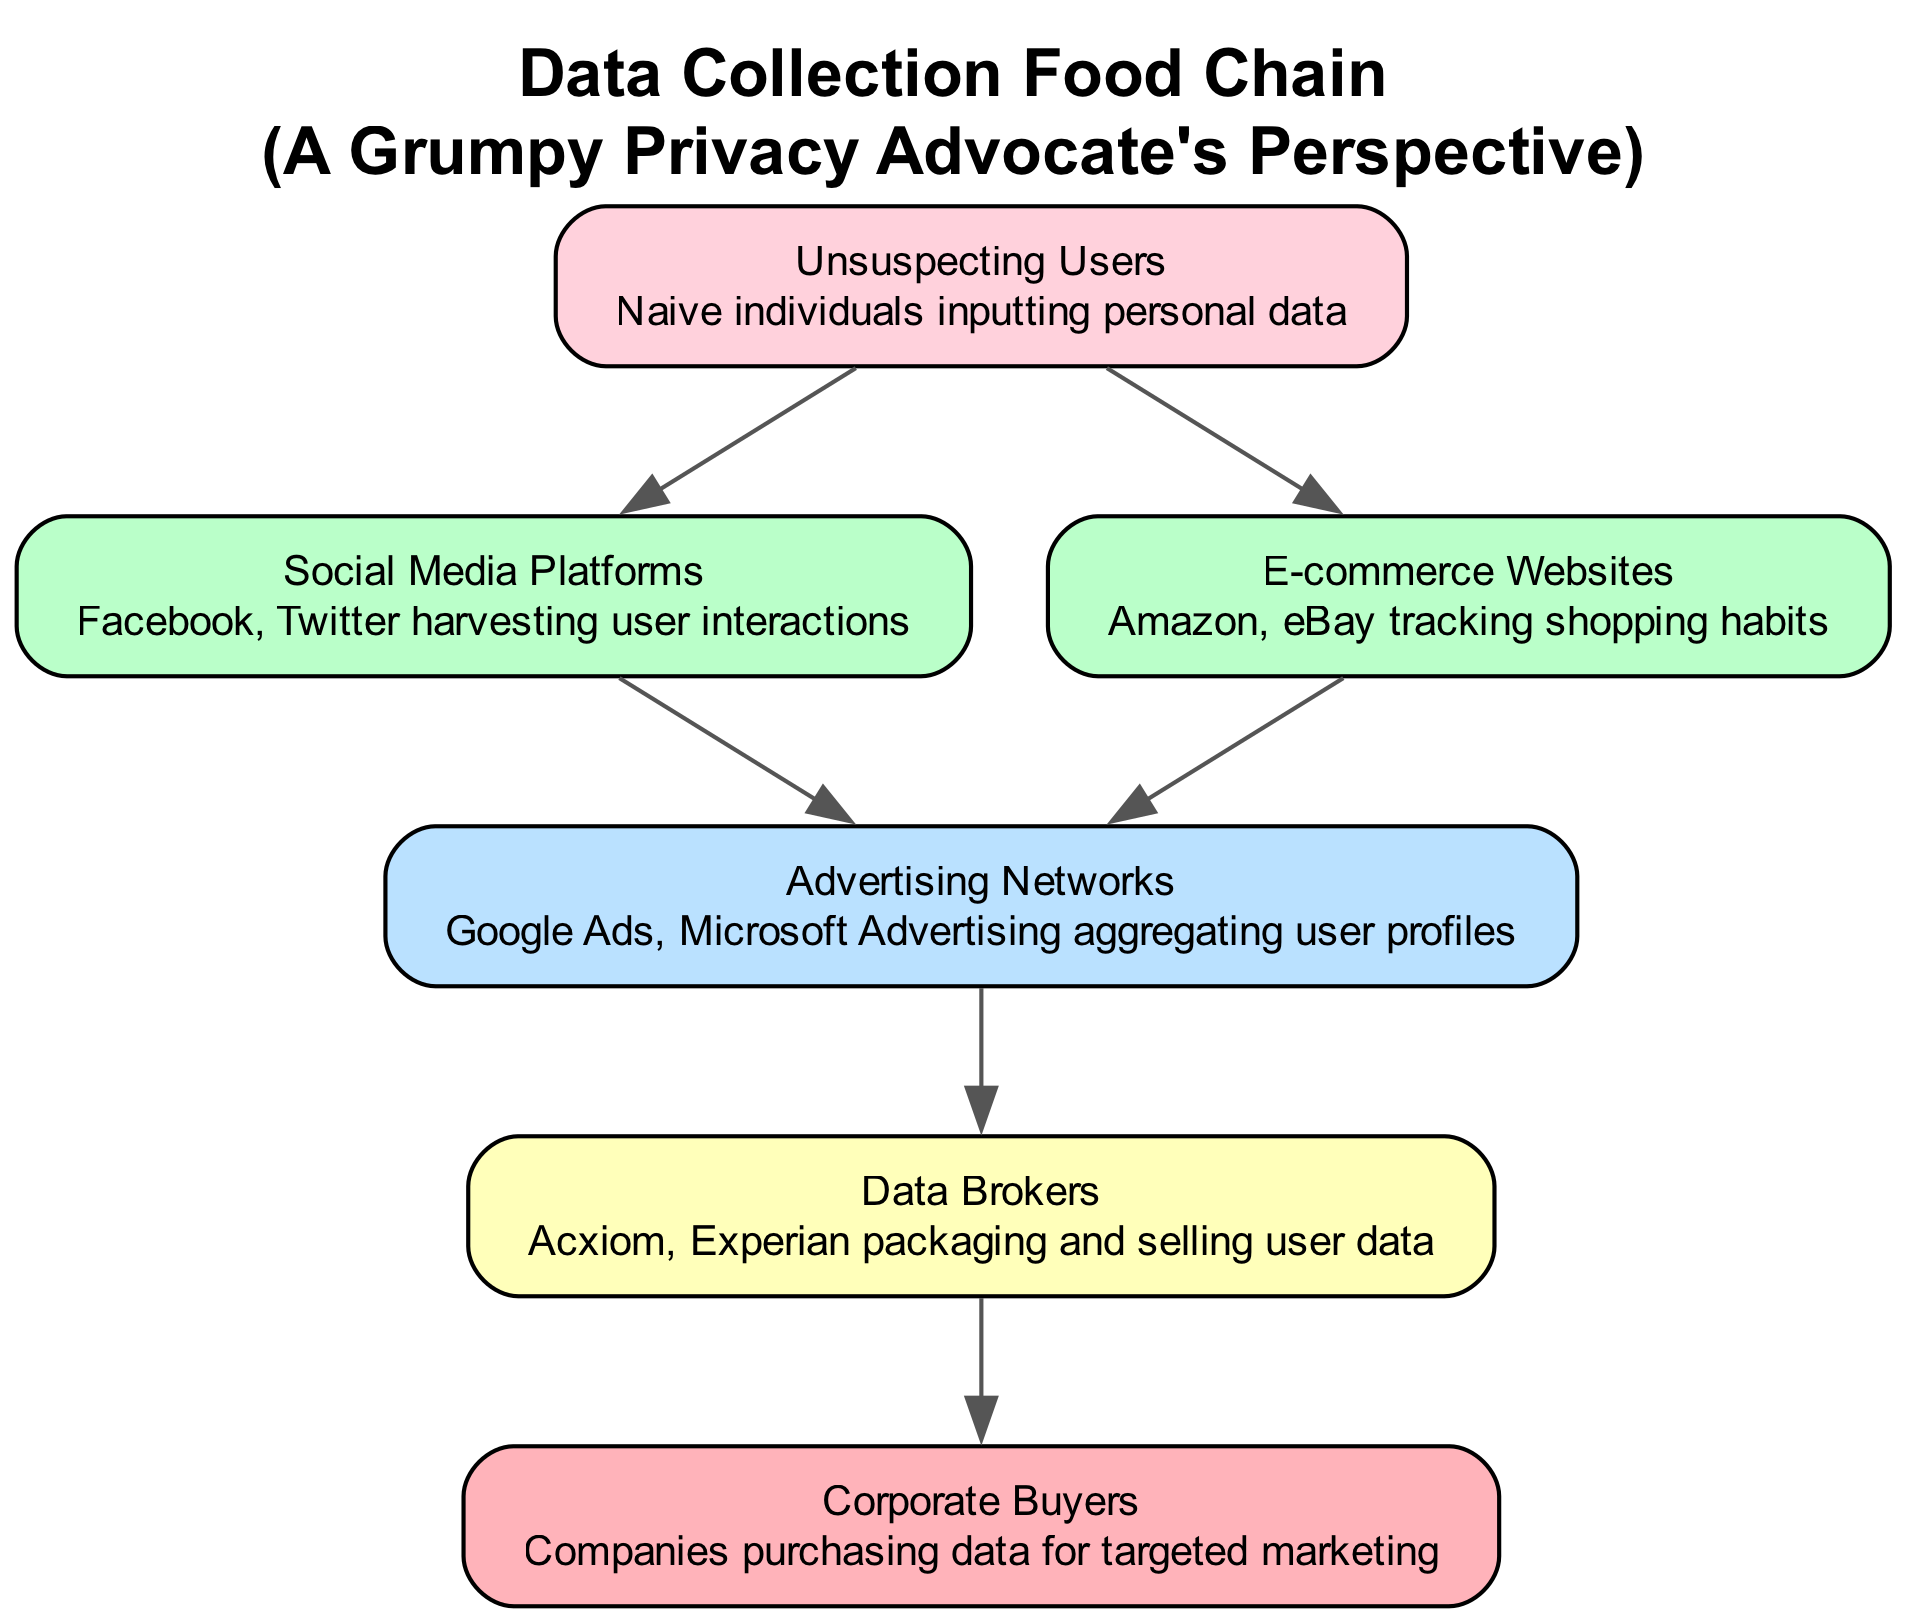What is the highest level in the food chain? The highest level in the food chain is determined by viewing the levels assigned to each element. The highest level present in the diagram is level 5, which corresponds to "Corporate Buyers."
Answer: Corporate Buyers How many nodes are in the food chain? To find the number of nodes, we count each distinct entity listed in the diagram. There are a total of 5 nodes—one for each of the entities: Unsuspecting Users, Social Media Platforms, E-commerce Websites, Advertising Networks, Data Brokers, and Corporate Buyers.
Answer: 6 Which platform collects data from unsuspecting users? The relationship in the food chain indicates that Social Media Platforms directly harvest information from Unsuspecting Users. We identify Social Media Platforms as the one that collects data from this level.
Answer: Social Media Platforms What entity sells user data? By analyzing the diagram's levels, we see that Data Brokers package and sell user data collected from sources like Advertising Networks. This is explicitly described in the food chain.
Answer: Data Brokers How many levels are in the food chain? The number of levels can be determined by reviewing the categorization of each listed entity. The chart outlines 5 distinct levels, from Unsuspecting Users to Corporate Buyers.
Answer: 5 Which networks are classified under Advertising Networks? The question inquires about a specification within the level. According to the diagram, the Advertising Networks include Google Ads and Microsoft Advertising.
Answer: Google Ads, Microsoft Advertising What is the relationship between Data Brokers and Corporate Buyers? To evaluate this relationship, we can see that the arrow from Data Brokers points toward Corporate Buyers, indicating that Corporate Buyers purchase data packaged and sold by the Data Brokers.
Answer: Corporate Buyers purchase from Data Brokers Which entity is the first step in the data collection process? By understanding the flow of the food chain, the first step is represented by the lowest level, which is Unsuspecting Users as the initial source of personal data.
Answer: Unsuspecting Users What do Advertising Networks do with user data? By reading the description in the diagram, Advertising Networks aggregate user profiles from various sources and construct a comprehensive understanding of user behavior.
Answer: Aggregate user profiles 